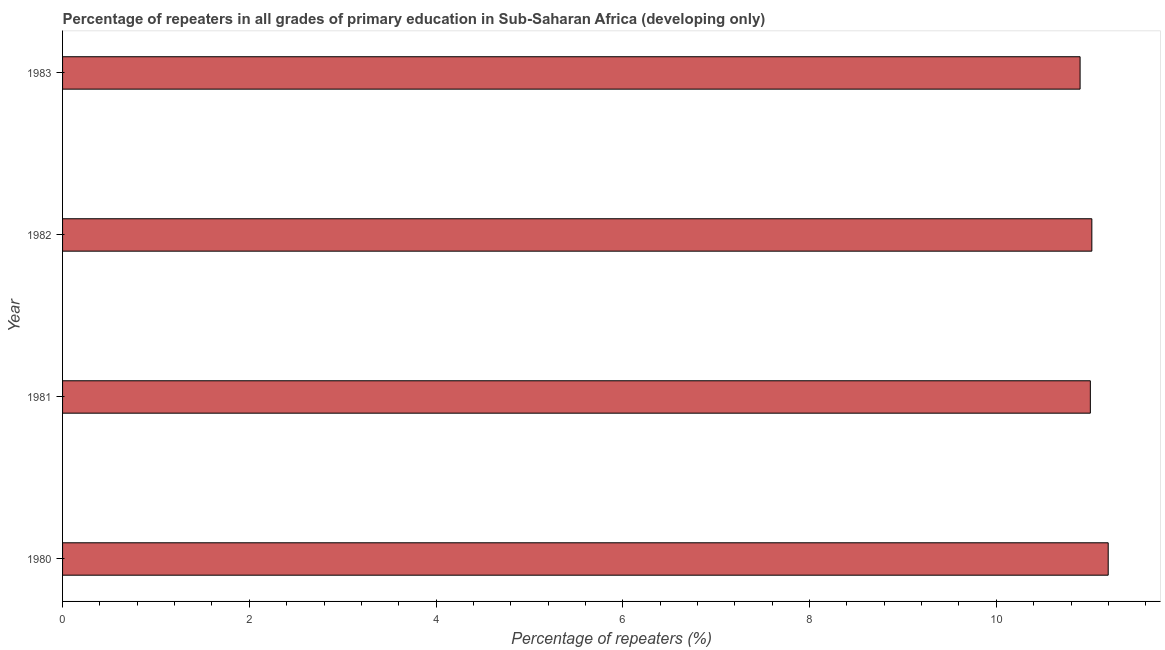Does the graph contain any zero values?
Offer a very short reply. No. What is the title of the graph?
Keep it short and to the point. Percentage of repeaters in all grades of primary education in Sub-Saharan Africa (developing only). What is the label or title of the X-axis?
Make the answer very short. Percentage of repeaters (%). What is the label or title of the Y-axis?
Your answer should be compact. Year. What is the percentage of repeaters in primary education in 1982?
Offer a very short reply. 11.02. Across all years, what is the maximum percentage of repeaters in primary education?
Provide a short and direct response. 11.2. Across all years, what is the minimum percentage of repeaters in primary education?
Keep it short and to the point. 10.9. In which year was the percentage of repeaters in primary education maximum?
Provide a succinct answer. 1980. What is the sum of the percentage of repeaters in primary education?
Your answer should be very brief. 44.13. What is the difference between the percentage of repeaters in primary education in 1980 and 1981?
Offer a terse response. 0.19. What is the average percentage of repeaters in primary education per year?
Offer a terse response. 11.03. What is the median percentage of repeaters in primary education?
Provide a short and direct response. 11.02. Do a majority of the years between 1983 and 1980 (inclusive) have percentage of repeaters in primary education greater than 3.2 %?
Offer a very short reply. Yes. What is the ratio of the percentage of repeaters in primary education in 1981 to that in 1982?
Give a very brief answer. 1. Is the difference between the percentage of repeaters in primary education in 1980 and 1983 greater than the difference between any two years?
Provide a short and direct response. Yes. What is the difference between the highest and the second highest percentage of repeaters in primary education?
Offer a very short reply. 0.17. What is the difference between the highest and the lowest percentage of repeaters in primary education?
Give a very brief answer. 0.3. In how many years, is the percentage of repeaters in primary education greater than the average percentage of repeaters in primary education taken over all years?
Keep it short and to the point. 1. What is the difference between two consecutive major ticks on the X-axis?
Provide a short and direct response. 2. Are the values on the major ticks of X-axis written in scientific E-notation?
Give a very brief answer. No. What is the Percentage of repeaters (%) in 1980?
Your answer should be very brief. 11.2. What is the Percentage of repeaters (%) in 1981?
Ensure brevity in your answer.  11.01. What is the Percentage of repeaters (%) in 1982?
Make the answer very short. 11.02. What is the Percentage of repeaters (%) of 1983?
Keep it short and to the point. 10.9. What is the difference between the Percentage of repeaters (%) in 1980 and 1981?
Provide a succinct answer. 0.19. What is the difference between the Percentage of repeaters (%) in 1980 and 1982?
Give a very brief answer. 0.18. What is the difference between the Percentage of repeaters (%) in 1980 and 1983?
Give a very brief answer. 0.3. What is the difference between the Percentage of repeaters (%) in 1981 and 1982?
Keep it short and to the point. -0.02. What is the difference between the Percentage of repeaters (%) in 1981 and 1983?
Your answer should be very brief. 0.11. What is the difference between the Percentage of repeaters (%) in 1982 and 1983?
Your answer should be very brief. 0.13. What is the ratio of the Percentage of repeaters (%) in 1980 to that in 1983?
Your response must be concise. 1.03. What is the ratio of the Percentage of repeaters (%) in 1981 to that in 1982?
Ensure brevity in your answer.  1. What is the ratio of the Percentage of repeaters (%) in 1981 to that in 1983?
Your answer should be very brief. 1.01. What is the ratio of the Percentage of repeaters (%) in 1982 to that in 1983?
Offer a terse response. 1.01. 